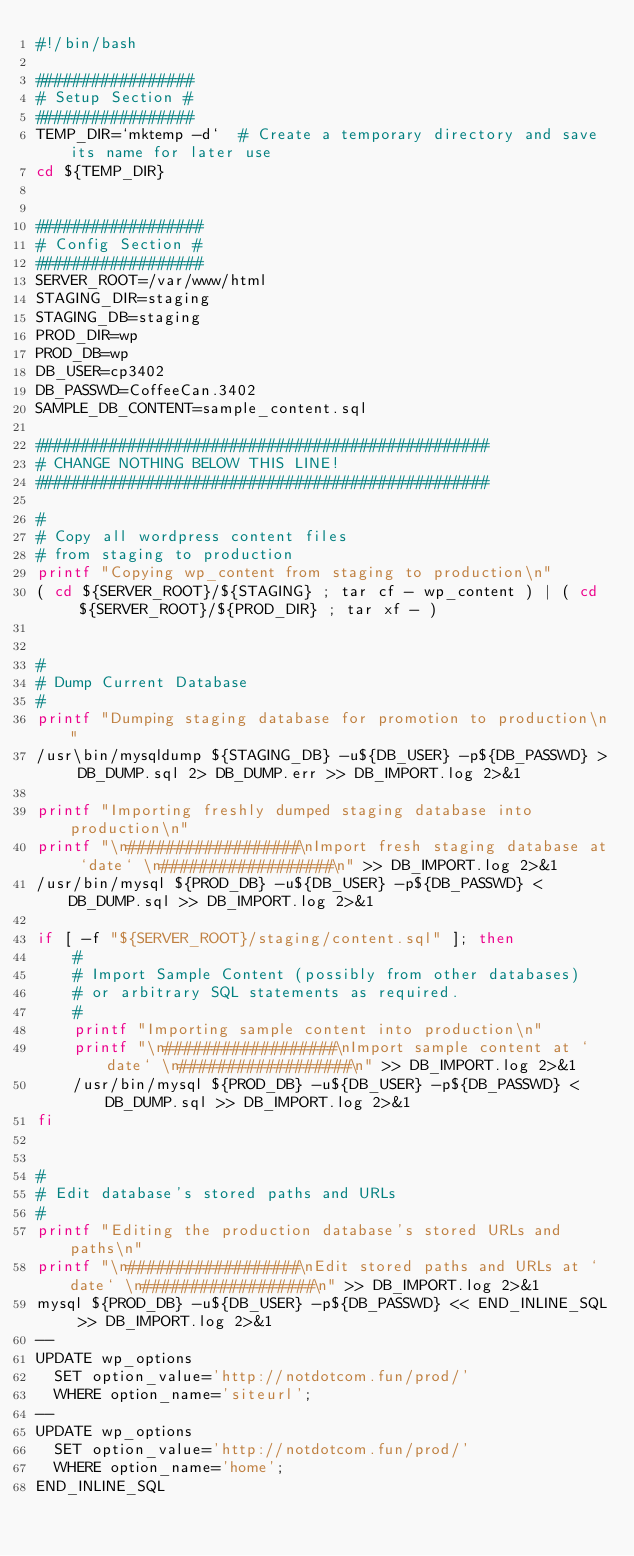<code> <loc_0><loc_0><loc_500><loc_500><_Bash_>#!/bin/bash

#################
# Setup Section #
#################
TEMP_DIR=`mktemp -d`  # Create a temporary directory and save its name for later use
cd ${TEMP_DIR}


##################
# Config Section #
##################
SERVER_ROOT=/var/www/html
STAGING_DIR=staging
STAGING_DB=staging
PROD_DIR=wp
PROD_DB=wp
DB_USER=cp3402
DB_PASSWD=CoffeeCan.3402
SAMPLE_DB_CONTENT=sample_content.sql

#################################################
# CHANGE NOTHING BELOW THIS LINE!
#################################################

#
# Copy all wordpress content files
# from staging to production 
printf "Copying wp_content from staging to production\n"
( cd ${SERVER_ROOT}/${STAGING} ; tar cf - wp_content ) | ( cd  ${SERVER_ROOT}/${PROD_DIR} ; tar xf - )


#
# Dump Current Database 
#
printf "Dumping staging database for promotion to production\n"
/usr\bin/mysqldump ${STAGING_DB} -u${DB_USER} -p${DB_PASSWD} > DB_DUMP.sql 2> DB_DUMP.err >> DB_IMPORT.log 2>&1

printf "Importing freshly dumped staging database into production\n"
printf "\n##################\nImport fresh staging database at `date` \n##################\n" >> DB_IMPORT.log 2>&1
/usr/bin/mysql ${PROD_DB} -u${DB_USER} -p${DB_PASSWD} < DB_DUMP.sql >> DB_IMPORT.log 2>&1

if [ -f "${SERVER_ROOT}/staging/content.sql" ]; then
    #
    # Import Sample Content (possibly from other databases)
    # or arbitrary SQL statements as required.
    #
    printf "Importing sample content into production\n"
    printf "\n##################\nImport sample content at `date` \n##################\n" >> DB_IMPORT.log 2>&1
    /usr/bin/mysql ${PROD_DB} -u${DB_USER} -p${DB_PASSWD} < DB_DUMP.sql >> DB_IMPORT.log 2>&1
fi


#
# Edit database's stored paths and URLs
#
printf "Editing the production database's stored URLs and paths\n"
printf "\n##################\nEdit stored paths and URLs at `date` \n##################\n" >> DB_IMPORT.log 2>&1
mysql ${PROD_DB} -u${DB_USER} -p${DB_PASSWD} << END_INLINE_SQL >> DB_IMPORT.log 2>&1
--
UPDATE wp_options 
  SET option_value='http://notdotcom.fun/prod/' 
  WHERE option_name='siteurl';
--
UPDATE wp_options 
  SET option_value='http://notdotcom.fun/prod/' 
  WHERE option_name='home';
END_INLINE_SQL 


</code> 